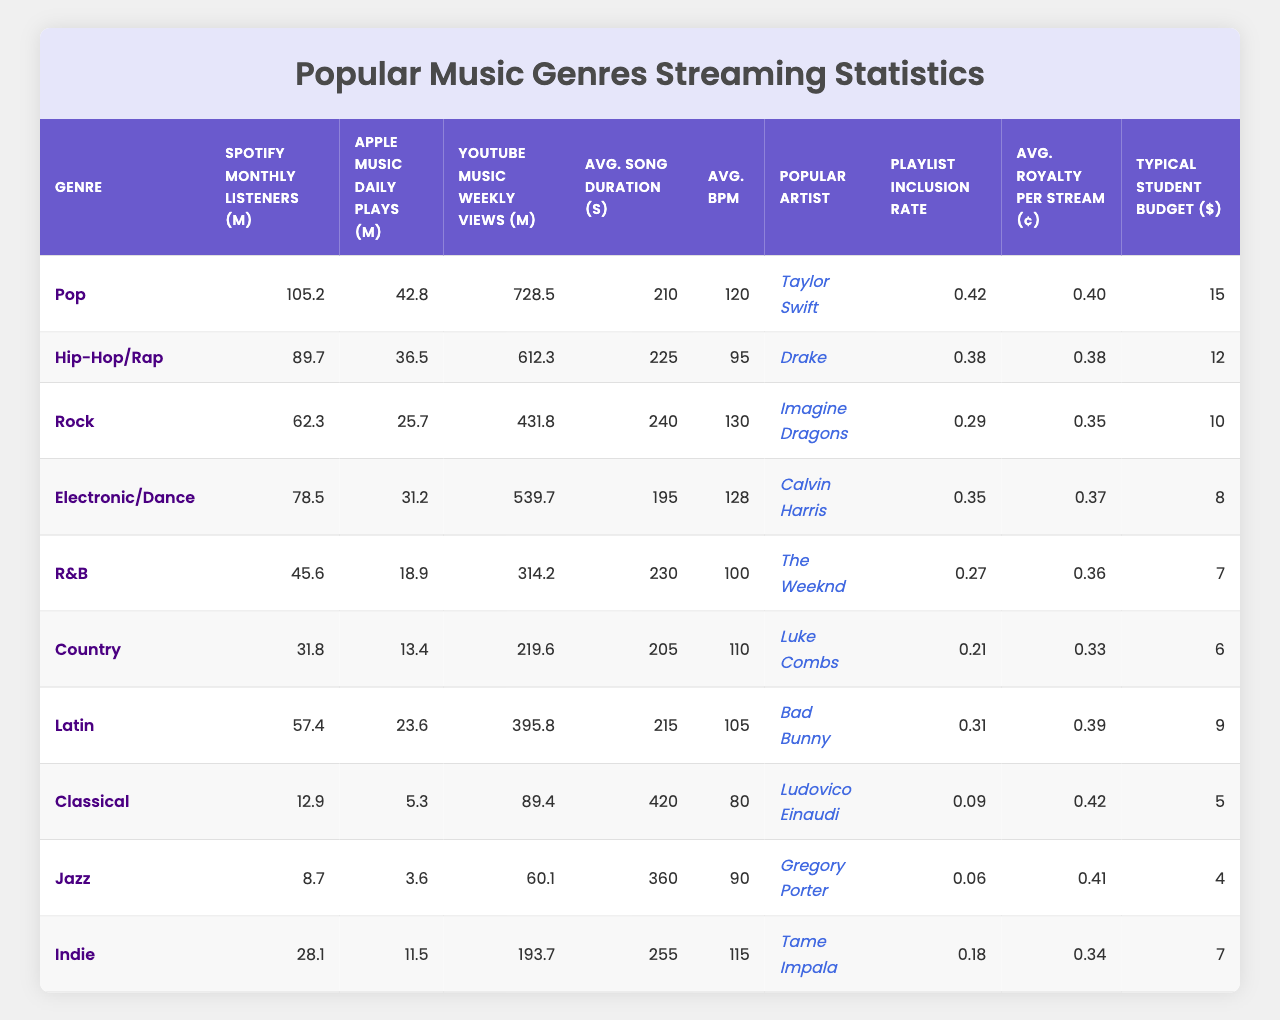What is the genre with the highest Spotify monthly listeners? The genre with the highest Spotify monthly listeners can be found by looking for the maximum value in the "Spotify Monthly Listeners (M)" column. The highest value is 105.2 million for Pop.
Answer: Pop How many YouTube Music weekly views does the Rock genre have? The Rock genre can be found in the "YouTube Music Weekly Views (M)" column. It shows a value of 431.8 million weekly views.
Answer: 431.8 million What is the average song duration for Hip-Hop/Rap? To find the average song duration for Hip-Hop/Rap, we look at the "Avg. Song Duration (s)" column. The Hip-Hop/Rap genre shows a duration of 225 seconds.
Answer: 225 seconds Which genre has the lowest average royalty per stream? By examining the "Avg. Royalty per Stream (¢)" column, we find that Country has the lowest value at 0.33 cents.
Answer: Country What is the typical student budget for the genre Jazz? Looking at the "Typical Student Budget ($)" column, Jazz has a typical student budget of 5 dollars.
Answer: 5 dollars Which genre has the highest playlist inclusion rate? The playlist inclusion rates can be compared, where the highest value found in the "Playlist Inclusion Rate" column is 0.42 for Pop.
Answer: Pop What is the difference in average beats per minute between Electronic/Dance and R&B? First, the average beats per minute for Electronic/Dance is 128, and for R&B, it is 100. The difference is calculated as 128 - 100 = 28.
Answer: 28 BPM How many more YouTube Music weekly views does Electronic/Dance have compared to Country? Electronic/Dance has 539.7 million views and Country has 219.6 million views. The difference is 539.7 - 219.6 = 320.1 million views.
Answer: 320.1 million Is the average song duration longer for Indie than for R&B? The average song duration for Indie is 255 seconds, while R&B has 230 seconds. Since 255 is greater than 230, the statement is true.
Answer: Yes Which genre has more Spotify monthly listeners: R&B or Latin? The R&B genre has 45.6 million listeners, while Latin has 57.4 million listeners. Since 57.4 million is greater than 45.6 million, Latin has more listeners.
Answer: Latin What is the average monetary value of the typical student budget across all genres? To calculate the average, we sum up the typical student budgets (15 + 12 + 10 + 8 + 7 + 6 + 9 + 5 + 4 + 7 = 78) and then divide by the number of genres (78/10 = 7.8).
Answer: 7.8 dollars Which genre has the highest YouTube Music weekly views and what is the value? By reviewing the values in the "YouTube Music Weekly Views (M)" column, we can see that Pop has the highest views at 728.5 million.
Answer: Pop, 728.5 million 